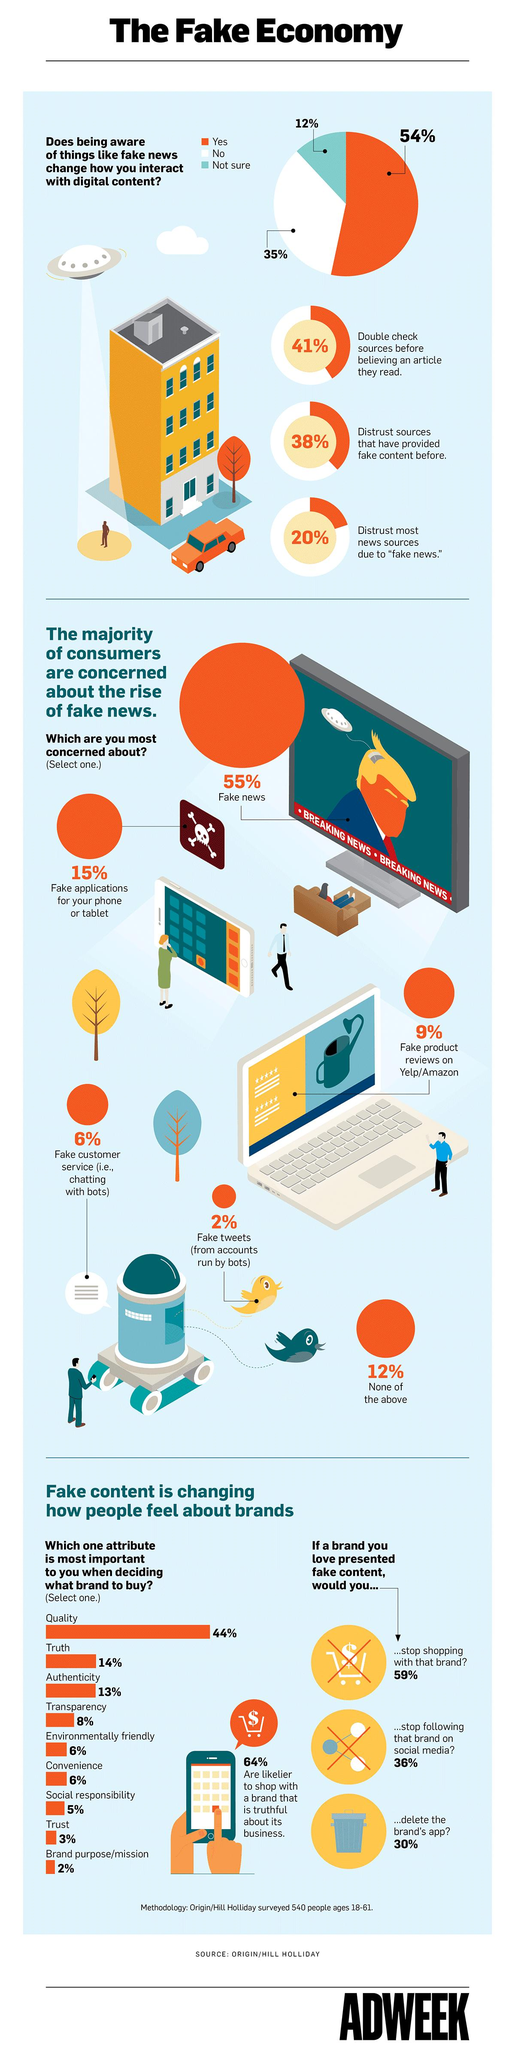Indicate a few pertinent items in this graphic. A recent survey found that 62% of people trust sources that have previously provided fake content. According to a survey, 57% of people consider authenticity and quality when deciding which brand to buy. According to the survey, 14% of people consider convenience and transparency when deciding which brand to buy. A large percentage, approximately 94%, of customer service is not fake. Seventeen percent of people consider truth and trust when deciding what brand to buy. 